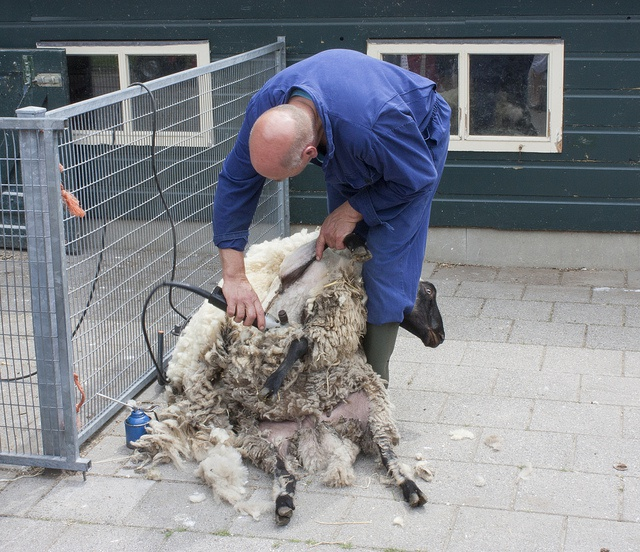Describe the objects in this image and their specific colors. I can see sheep in darkblue, darkgray, gray, lightgray, and black tones and people in darkblue, navy, black, and blue tones in this image. 